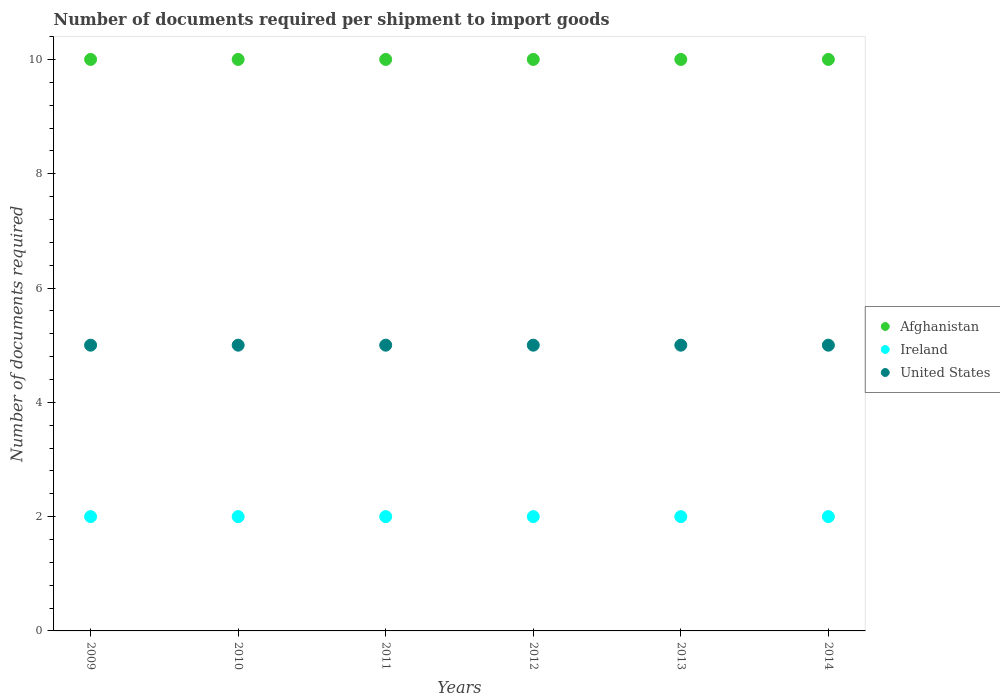How many different coloured dotlines are there?
Offer a terse response. 3. What is the number of documents required per shipment to import goods in Ireland in 2010?
Provide a short and direct response. 2. Across all years, what is the maximum number of documents required per shipment to import goods in Afghanistan?
Offer a very short reply. 10. Across all years, what is the minimum number of documents required per shipment to import goods in Ireland?
Give a very brief answer. 2. In which year was the number of documents required per shipment to import goods in Ireland minimum?
Give a very brief answer. 2009. What is the total number of documents required per shipment to import goods in Ireland in the graph?
Provide a short and direct response. 12. What is the difference between the number of documents required per shipment to import goods in Afghanistan in 2011 and the number of documents required per shipment to import goods in United States in 2010?
Keep it short and to the point. 5. What is the average number of documents required per shipment to import goods in Ireland per year?
Provide a short and direct response. 2. In the year 2014, what is the difference between the number of documents required per shipment to import goods in Afghanistan and number of documents required per shipment to import goods in United States?
Offer a very short reply. 5. Is the difference between the number of documents required per shipment to import goods in Afghanistan in 2011 and 2012 greater than the difference between the number of documents required per shipment to import goods in United States in 2011 and 2012?
Your answer should be compact. No. What is the difference between the highest and the lowest number of documents required per shipment to import goods in Ireland?
Provide a succinct answer. 0. In how many years, is the number of documents required per shipment to import goods in United States greater than the average number of documents required per shipment to import goods in United States taken over all years?
Make the answer very short. 0. Is it the case that in every year, the sum of the number of documents required per shipment to import goods in United States and number of documents required per shipment to import goods in Ireland  is greater than the number of documents required per shipment to import goods in Afghanistan?
Ensure brevity in your answer.  No. Does the number of documents required per shipment to import goods in United States monotonically increase over the years?
Your response must be concise. No. What is the difference between two consecutive major ticks on the Y-axis?
Your answer should be compact. 2. Are the values on the major ticks of Y-axis written in scientific E-notation?
Your response must be concise. No. Does the graph contain grids?
Keep it short and to the point. No. Where does the legend appear in the graph?
Give a very brief answer. Center right. How many legend labels are there?
Give a very brief answer. 3. How are the legend labels stacked?
Offer a very short reply. Vertical. What is the title of the graph?
Give a very brief answer. Number of documents required per shipment to import goods. Does "Dominica" appear as one of the legend labels in the graph?
Offer a terse response. No. What is the label or title of the X-axis?
Offer a very short reply. Years. What is the label or title of the Y-axis?
Your response must be concise. Number of documents required. What is the Number of documents required in Afghanistan in 2009?
Ensure brevity in your answer.  10. What is the Number of documents required in United States in 2009?
Keep it short and to the point. 5. What is the Number of documents required of United States in 2010?
Provide a succinct answer. 5. What is the Number of documents required of United States in 2011?
Make the answer very short. 5. What is the Number of documents required in Ireland in 2012?
Your response must be concise. 2. What is the Number of documents required of Afghanistan in 2013?
Your answer should be compact. 10. What is the Number of documents required of Ireland in 2013?
Ensure brevity in your answer.  2. Across all years, what is the maximum Number of documents required of United States?
Your answer should be very brief. 5. Across all years, what is the minimum Number of documents required of Ireland?
Your answer should be compact. 2. What is the total Number of documents required of United States in the graph?
Provide a succinct answer. 30. What is the difference between the Number of documents required in Afghanistan in 2009 and that in 2010?
Offer a terse response. 0. What is the difference between the Number of documents required in Ireland in 2009 and that in 2010?
Provide a short and direct response. 0. What is the difference between the Number of documents required in United States in 2009 and that in 2010?
Your response must be concise. 0. What is the difference between the Number of documents required in Afghanistan in 2009 and that in 2011?
Offer a very short reply. 0. What is the difference between the Number of documents required in Afghanistan in 2009 and that in 2012?
Your answer should be very brief. 0. What is the difference between the Number of documents required of Ireland in 2009 and that in 2012?
Offer a terse response. 0. What is the difference between the Number of documents required in United States in 2009 and that in 2012?
Your answer should be very brief. 0. What is the difference between the Number of documents required in Ireland in 2009 and that in 2014?
Provide a short and direct response. 0. What is the difference between the Number of documents required of United States in 2009 and that in 2014?
Ensure brevity in your answer.  0. What is the difference between the Number of documents required of Afghanistan in 2010 and that in 2011?
Your answer should be compact. 0. What is the difference between the Number of documents required in Afghanistan in 2010 and that in 2012?
Provide a short and direct response. 0. What is the difference between the Number of documents required in United States in 2010 and that in 2012?
Give a very brief answer. 0. What is the difference between the Number of documents required of Afghanistan in 2010 and that in 2013?
Keep it short and to the point. 0. What is the difference between the Number of documents required in Ireland in 2010 and that in 2013?
Give a very brief answer. 0. What is the difference between the Number of documents required of United States in 2010 and that in 2013?
Offer a terse response. 0. What is the difference between the Number of documents required in Afghanistan in 2011 and that in 2012?
Give a very brief answer. 0. What is the difference between the Number of documents required in Ireland in 2011 and that in 2012?
Keep it short and to the point. 0. What is the difference between the Number of documents required of Ireland in 2011 and that in 2013?
Make the answer very short. 0. What is the difference between the Number of documents required in United States in 2011 and that in 2013?
Provide a succinct answer. 0. What is the difference between the Number of documents required of Afghanistan in 2011 and that in 2014?
Provide a succinct answer. 0. What is the difference between the Number of documents required of Ireland in 2011 and that in 2014?
Offer a terse response. 0. What is the difference between the Number of documents required in United States in 2011 and that in 2014?
Keep it short and to the point. 0. What is the difference between the Number of documents required of United States in 2012 and that in 2013?
Offer a very short reply. 0. What is the difference between the Number of documents required in Afghanistan in 2012 and that in 2014?
Ensure brevity in your answer.  0. What is the difference between the Number of documents required in Ireland in 2012 and that in 2014?
Provide a succinct answer. 0. What is the difference between the Number of documents required of United States in 2012 and that in 2014?
Make the answer very short. 0. What is the difference between the Number of documents required in Ireland in 2013 and that in 2014?
Your answer should be compact. 0. What is the difference between the Number of documents required in United States in 2013 and that in 2014?
Your answer should be compact. 0. What is the difference between the Number of documents required in Ireland in 2009 and the Number of documents required in United States in 2010?
Your response must be concise. -3. What is the difference between the Number of documents required of Afghanistan in 2009 and the Number of documents required of Ireland in 2011?
Offer a terse response. 8. What is the difference between the Number of documents required in Afghanistan in 2009 and the Number of documents required in United States in 2011?
Offer a terse response. 5. What is the difference between the Number of documents required in Ireland in 2009 and the Number of documents required in United States in 2011?
Offer a very short reply. -3. What is the difference between the Number of documents required of Afghanistan in 2009 and the Number of documents required of Ireland in 2012?
Keep it short and to the point. 8. What is the difference between the Number of documents required in Afghanistan in 2009 and the Number of documents required in United States in 2012?
Keep it short and to the point. 5. What is the difference between the Number of documents required of Afghanistan in 2009 and the Number of documents required of United States in 2013?
Offer a terse response. 5. What is the difference between the Number of documents required of Ireland in 2009 and the Number of documents required of United States in 2013?
Offer a very short reply. -3. What is the difference between the Number of documents required in Afghanistan in 2009 and the Number of documents required in Ireland in 2014?
Give a very brief answer. 8. What is the difference between the Number of documents required of Afghanistan in 2009 and the Number of documents required of United States in 2014?
Your answer should be compact. 5. What is the difference between the Number of documents required of Afghanistan in 2010 and the Number of documents required of Ireland in 2012?
Ensure brevity in your answer.  8. What is the difference between the Number of documents required in Ireland in 2010 and the Number of documents required in United States in 2012?
Make the answer very short. -3. What is the difference between the Number of documents required of Ireland in 2010 and the Number of documents required of United States in 2013?
Offer a terse response. -3. What is the difference between the Number of documents required in Ireland in 2010 and the Number of documents required in United States in 2014?
Offer a terse response. -3. What is the difference between the Number of documents required of Afghanistan in 2011 and the Number of documents required of Ireland in 2012?
Offer a very short reply. 8. What is the difference between the Number of documents required in Ireland in 2011 and the Number of documents required in United States in 2012?
Your answer should be compact. -3. What is the difference between the Number of documents required in Afghanistan in 2011 and the Number of documents required in Ireland in 2013?
Ensure brevity in your answer.  8. What is the difference between the Number of documents required in Afghanistan in 2011 and the Number of documents required in United States in 2013?
Make the answer very short. 5. What is the difference between the Number of documents required of Ireland in 2011 and the Number of documents required of United States in 2013?
Keep it short and to the point. -3. What is the difference between the Number of documents required in Afghanistan in 2012 and the Number of documents required in Ireland in 2013?
Offer a very short reply. 8. What is the difference between the Number of documents required in Ireland in 2012 and the Number of documents required in United States in 2013?
Provide a succinct answer. -3. What is the difference between the Number of documents required in Afghanistan in 2012 and the Number of documents required in Ireland in 2014?
Provide a succinct answer. 8. What is the difference between the Number of documents required of Afghanistan in 2012 and the Number of documents required of United States in 2014?
Keep it short and to the point. 5. What is the difference between the Number of documents required in Ireland in 2012 and the Number of documents required in United States in 2014?
Offer a very short reply. -3. What is the difference between the Number of documents required of Afghanistan in 2013 and the Number of documents required of Ireland in 2014?
Offer a terse response. 8. What is the difference between the Number of documents required in Ireland in 2013 and the Number of documents required in United States in 2014?
Give a very brief answer. -3. In the year 2009, what is the difference between the Number of documents required in Afghanistan and Number of documents required in Ireland?
Make the answer very short. 8. In the year 2009, what is the difference between the Number of documents required of Afghanistan and Number of documents required of United States?
Make the answer very short. 5. In the year 2010, what is the difference between the Number of documents required in Afghanistan and Number of documents required in Ireland?
Keep it short and to the point. 8. In the year 2010, what is the difference between the Number of documents required of Ireland and Number of documents required of United States?
Offer a very short reply. -3. In the year 2011, what is the difference between the Number of documents required of Afghanistan and Number of documents required of Ireland?
Offer a very short reply. 8. In the year 2012, what is the difference between the Number of documents required of Afghanistan and Number of documents required of Ireland?
Keep it short and to the point. 8. In the year 2012, what is the difference between the Number of documents required of Afghanistan and Number of documents required of United States?
Your answer should be compact. 5. In the year 2013, what is the difference between the Number of documents required of Afghanistan and Number of documents required of United States?
Your response must be concise. 5. In the year 2014, what is the difference between the Number of documents required in Afghanistan and Number of documents required in United States?
Your answer should be very brief. 5. What is the ratio of the Number of documents required of Afghanistan in 2009 to that in 2010?
Give a very brief answer. 1. What is the ratio of the Number of documents required in Afghanistan in 2009 to that in 2011?
Your answer should be compact. 1. What is the ratio of the Number of documents required in United States in 2009 to that in 2011?
Your answer should be very brief. 1. What is the ratio of the Number of documents required of Ireland in 2009 to that in 2012?
Provide a short and direct response. 1. What is the ratio of the Number of documents required in Afghanistan in 2009 to that in 2013?
Your answer should be very brief. 1. What is the ratio of the Number of documents required of Afghanistan in 2009 to that in 2014?
Provide a succinct answer. 1. What is the ratio of the Number of documents required of Ireland in 2009 to that in 2014?
Your answer should be very brief. 1. What is the ratio of the Number of documents required of Ireland in 2010 to that in 2011?
Your response must be concise. 1. What is the ratio of the Number of documents required in Afghanistan in 2010 to that in 2012?
Provide a short and direct response. 1. What is the ratio of the Number of documents required in Ireland in 2010 to that in 2012?
Provide a short and direct response. 1. What is the ratio of the Number of documents required of United States in 2010 to that in 2012?
Your answer should be very brief. 1. What is the ratio of the Number of documents required of Ireland in 2010 to that in 2013?
Provide a succinct answer. 1. What is the ratio of the Number of documents required in United States in 2010 to that in 2013?
Your answer should be compact. 1. What is the ratio of the Number of documents required of Afghanistan in 2010 to that in 2014?
Give a very brief answer. 1. What is the ratio of the Number of documents required of Ireland in 2010 to that in 2014?
Offer a terse response. 1. What is the ratio of the Number of documents required of Afghanistan in 2011 to that in 2012?
Your answer should be compact. 1. What is the ratio of the Number of documents required in Ireland in 2011 to that in 2013?
Ensure brevity in your answer.  1. What is the ratio of the Number of documents required in United States in 2011 to that in 2013?
Your answer should be compact. 1. What is the ratio of the Number of documents required in Afghanistan in 2011 to that in 2014?
Offer a very short reply. 1. What is the ratio of the Number of documents required of United States in 2011 to that in 2014?
Make the answer very short. 1. What is the ratio of the Number of documents required of Afghanistan in 2012 to that in 2013?
Keep it short and to the point. 1. What is the ratio of the Number of documents required in Ireland in 2012 to that in 2013?
Provide a short and direct response. 1. What is the ratio of the Number of documents required of Afghanistan in 2012 to that in 2014?
Offer a very short reply. 1. What is the difference between the highest and the second highest Number of documents required of Afghanistan?
Your answer should be compact. 0. What is the difference between the highest and the second highest Number of documents required in Ireland?
Offer a terse response. 0. What is the difference between the highest and the lowest Number of documents required of Afghanistan?
Keep it short and to the point. 0. What is the difference between the highest and the lowest Number of documents required in Ireland?
Give a very brief answer. 0. What is the difference between the highest and the lowest Number of documents required of United States?
Keep it short and to the point. 0. 